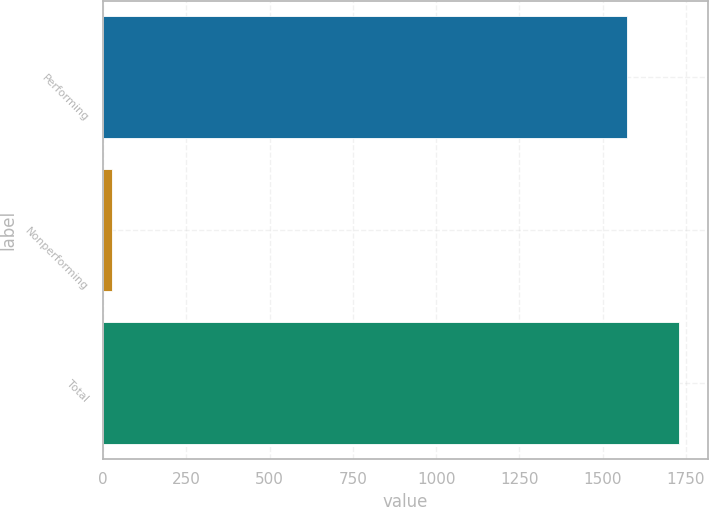Convert chart to OTSL. <chart><loc_0><loc_0><loc_500><loc_500><bar_chart><fcel>Performing<fcel>Nonperforming<fcel>Total<nl><fcel>1573.1<fcel>28<fcel>1730.41<nl></chart> 